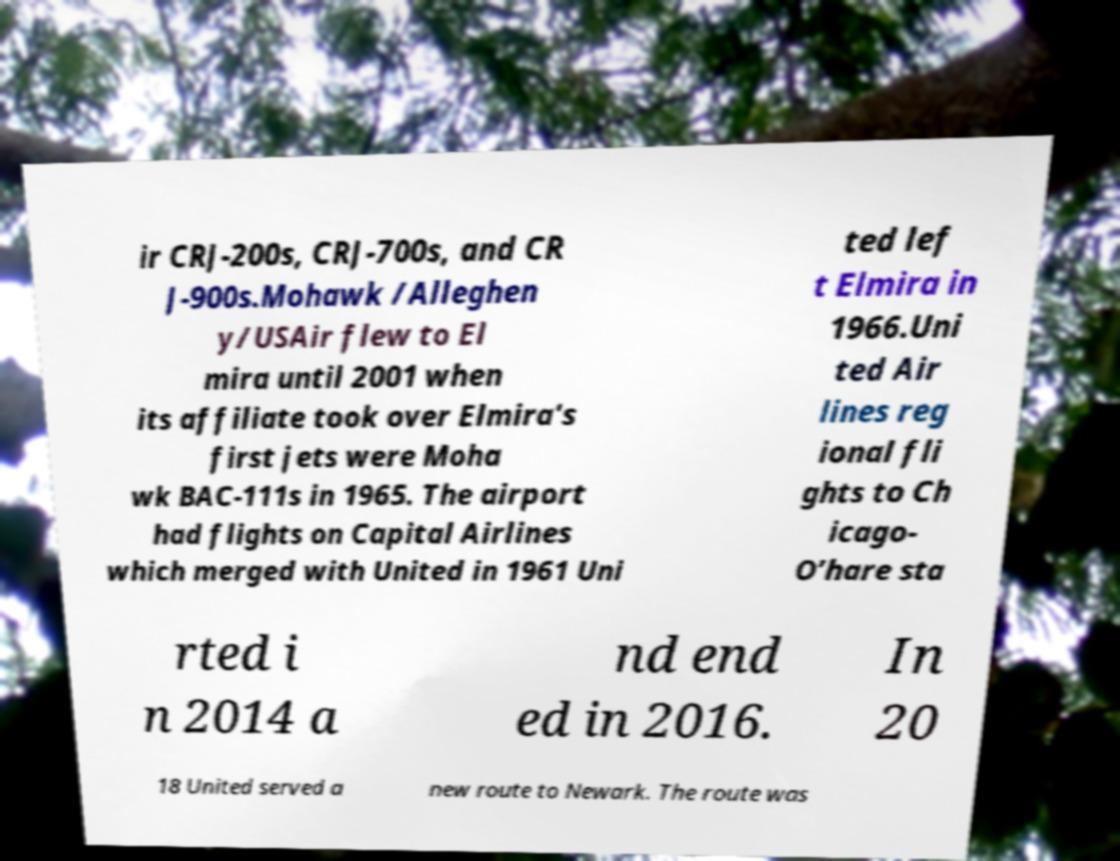For documentation purposes, I need the text within this image transcribed. Could you provide that? ir CRJ-200s, CRJ-700s, and CR J-900s.Mohawk /Alleghen y/USAir flew to El mira until 2001 when its affiliate took over Elmira's first jets were Moha wk BAC-111s in 1965. The airport had flights on Capital Airlines which merged with United in 1961 Uni ted lef t Elmira in 1966.Uni ted Air lines reg ional fli ghts to Ch icago- O’hare sta rted i n 2014 a nd end ed in 2016. In 20 18 United served a new route to Newark. The route was 